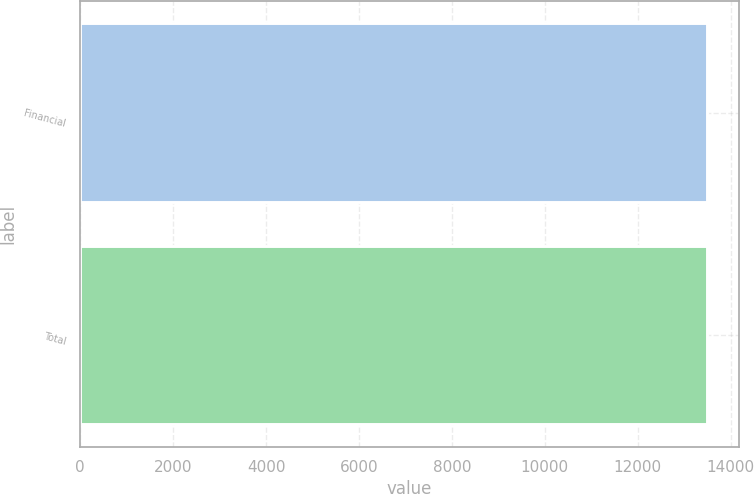Convert chart to OTSL. <chart><loc_0><loc_0><loc_500><loc_500><bar_chart><fcel>Financial<fcel>Total<nl><fcel>13500<fcel>13500.1<nl></chart> 